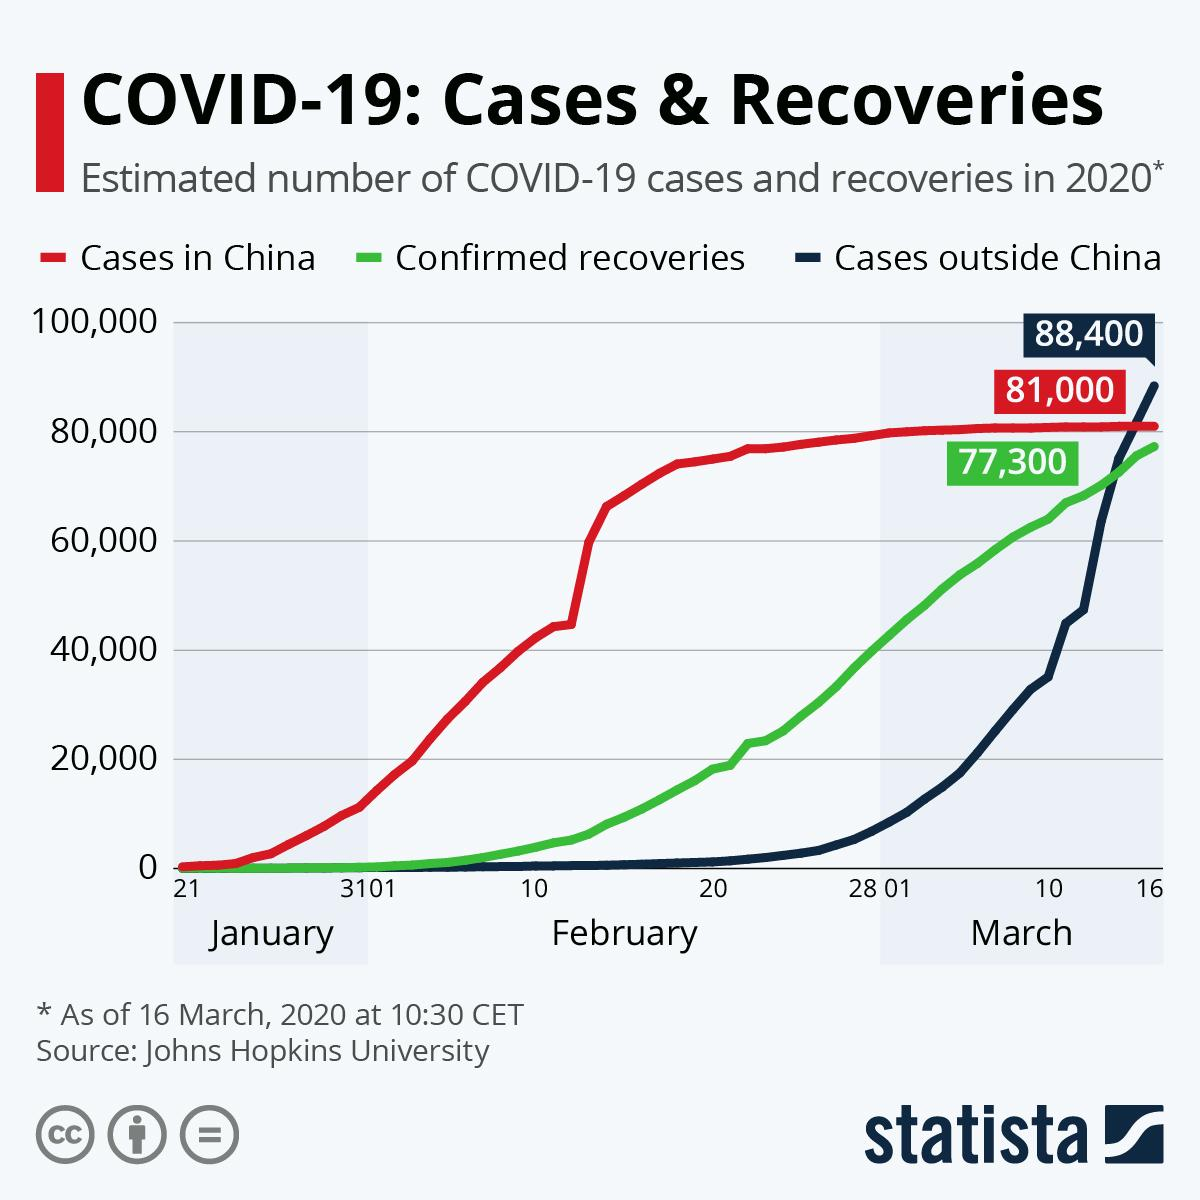Specify some key components in this picture. The difference between cases in China and confirmed recoveries is 3,700. Cases of COVID-19 outside of China are higher than the number of confirmed recoveries and cases within China. 